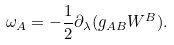Convert formula to latex. <formula><loc_0><loc_0><loc_500><loc_500>\omega _ { A } = - \frac { 1 } { 2 } \partial _ { \lambda } ( g _ { A B } W ^ { B } ) .</formula> 